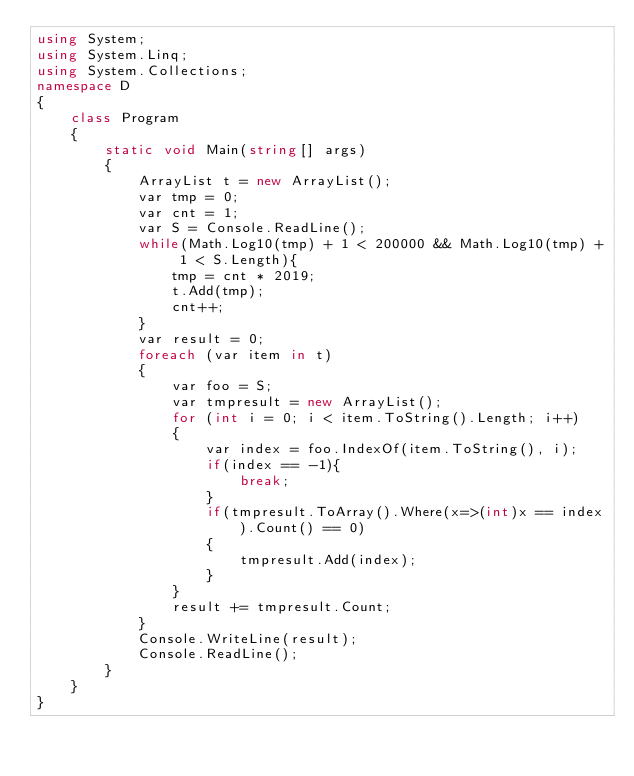<code> <loc_0><loc_0><loc_500><loc_500><_C#_>using System;
using System.Linq;
using System.Collections;
namespace D
{
    class Program
    {
        static void Main(string[] args)
        {
            ArrayList t = new ArrayList();
            var tmp = 0;
            var cnt = 1;
            var S = Console.ReadLine();
            while(Math.Log10(tmp) + 1 < 200000 && Math.Log10(tmp) + 1 < S.Length){
                tmp = cnt * 2019;
                t.Add(tmp);
                cnt++;
            }
            var result = 0;
            foreach (var item in t)
            {
                var foo = S;
                var tmpresult = new ArrayList();
                for (int i = 0; i < item.ToString().Length; i++)
                {
                    var index = foo.IndexOf(item.ToString(), i);
                    if(index == -1){
                        break;
                    }
                    if(tmpresult.ToArray().Where(x=>(int)x == index).Count() == 0)
                    {
                        tmpresult.Add(index);
                    }
                }
                result += tmpresult.Count;
            }
            Console.WriteLine(result);
            Console.ReadLine();
        }
    }
}
</code> 